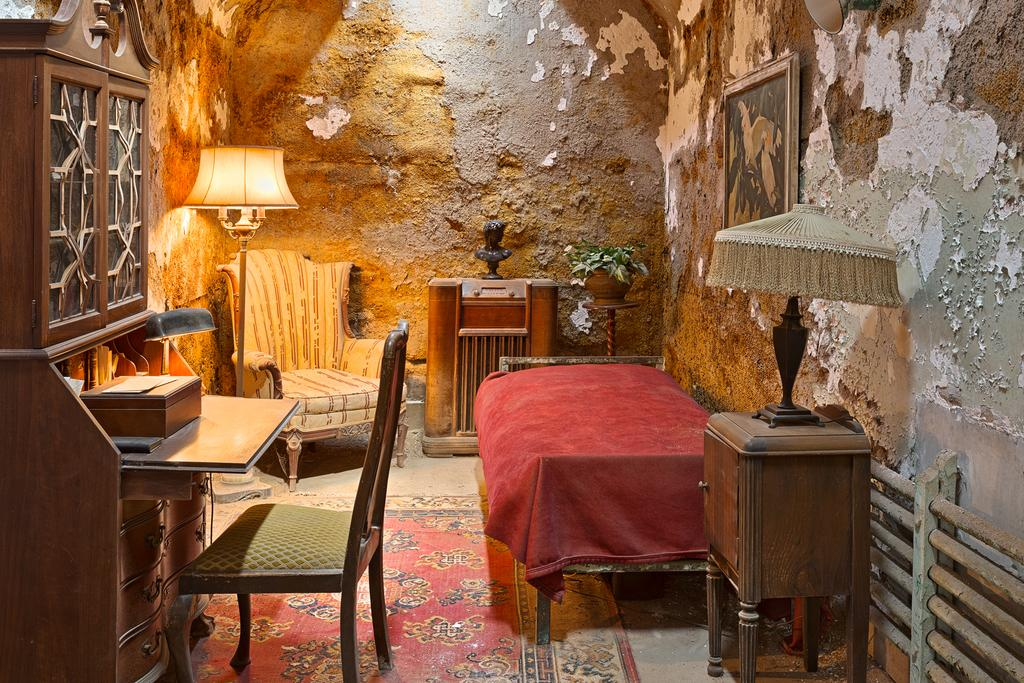What type of furniture is present in the room? There is a bed, a chair, a table, and cupboards in the room. What is on the table in the room? There is a box and a lamp on the table in the room. What is hanging on the wall in the room? There is a frame hanging on the wall in the room. What can be found near the bed in the room? There is a flower pot with a plant in it near the bed in the room. How many toys are on the bed in the image? There are no toys mentioned or visible in the image. What is the servant doing in the room? There is no mention of a servant in the image or the provided facts. 